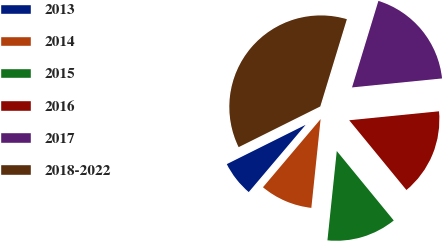<chart> <loc_0><loc_0><loc_500><loc_500><pie_chart><fcel>2013<fcel>2014<fcel>2015<fcel>2016<fcel>2017<fcel>2018-2022<nl><fcel>6.46%<fcel>9.52%<fcel>12.59%<fcel>15.65%<fcel>18.71%<fcel>37.07%<nl></chart> 